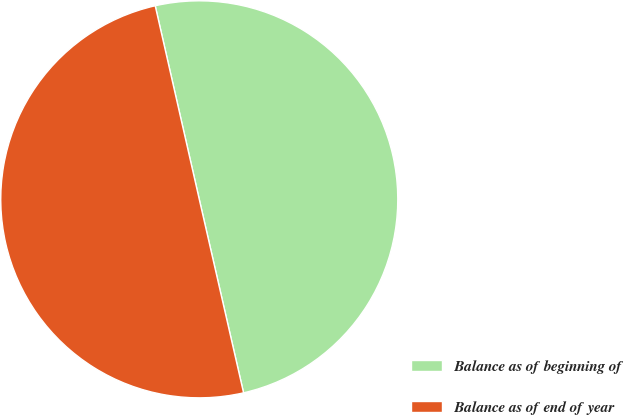Convert chart. <chart><loc_0><loc_0><loc_500><loc_500><pie_chart><fcel>Balance as of beginning of<fcel>Balance as of end of year<nl><fcel>49.98%<fcel>50.02%<nl></chart> 